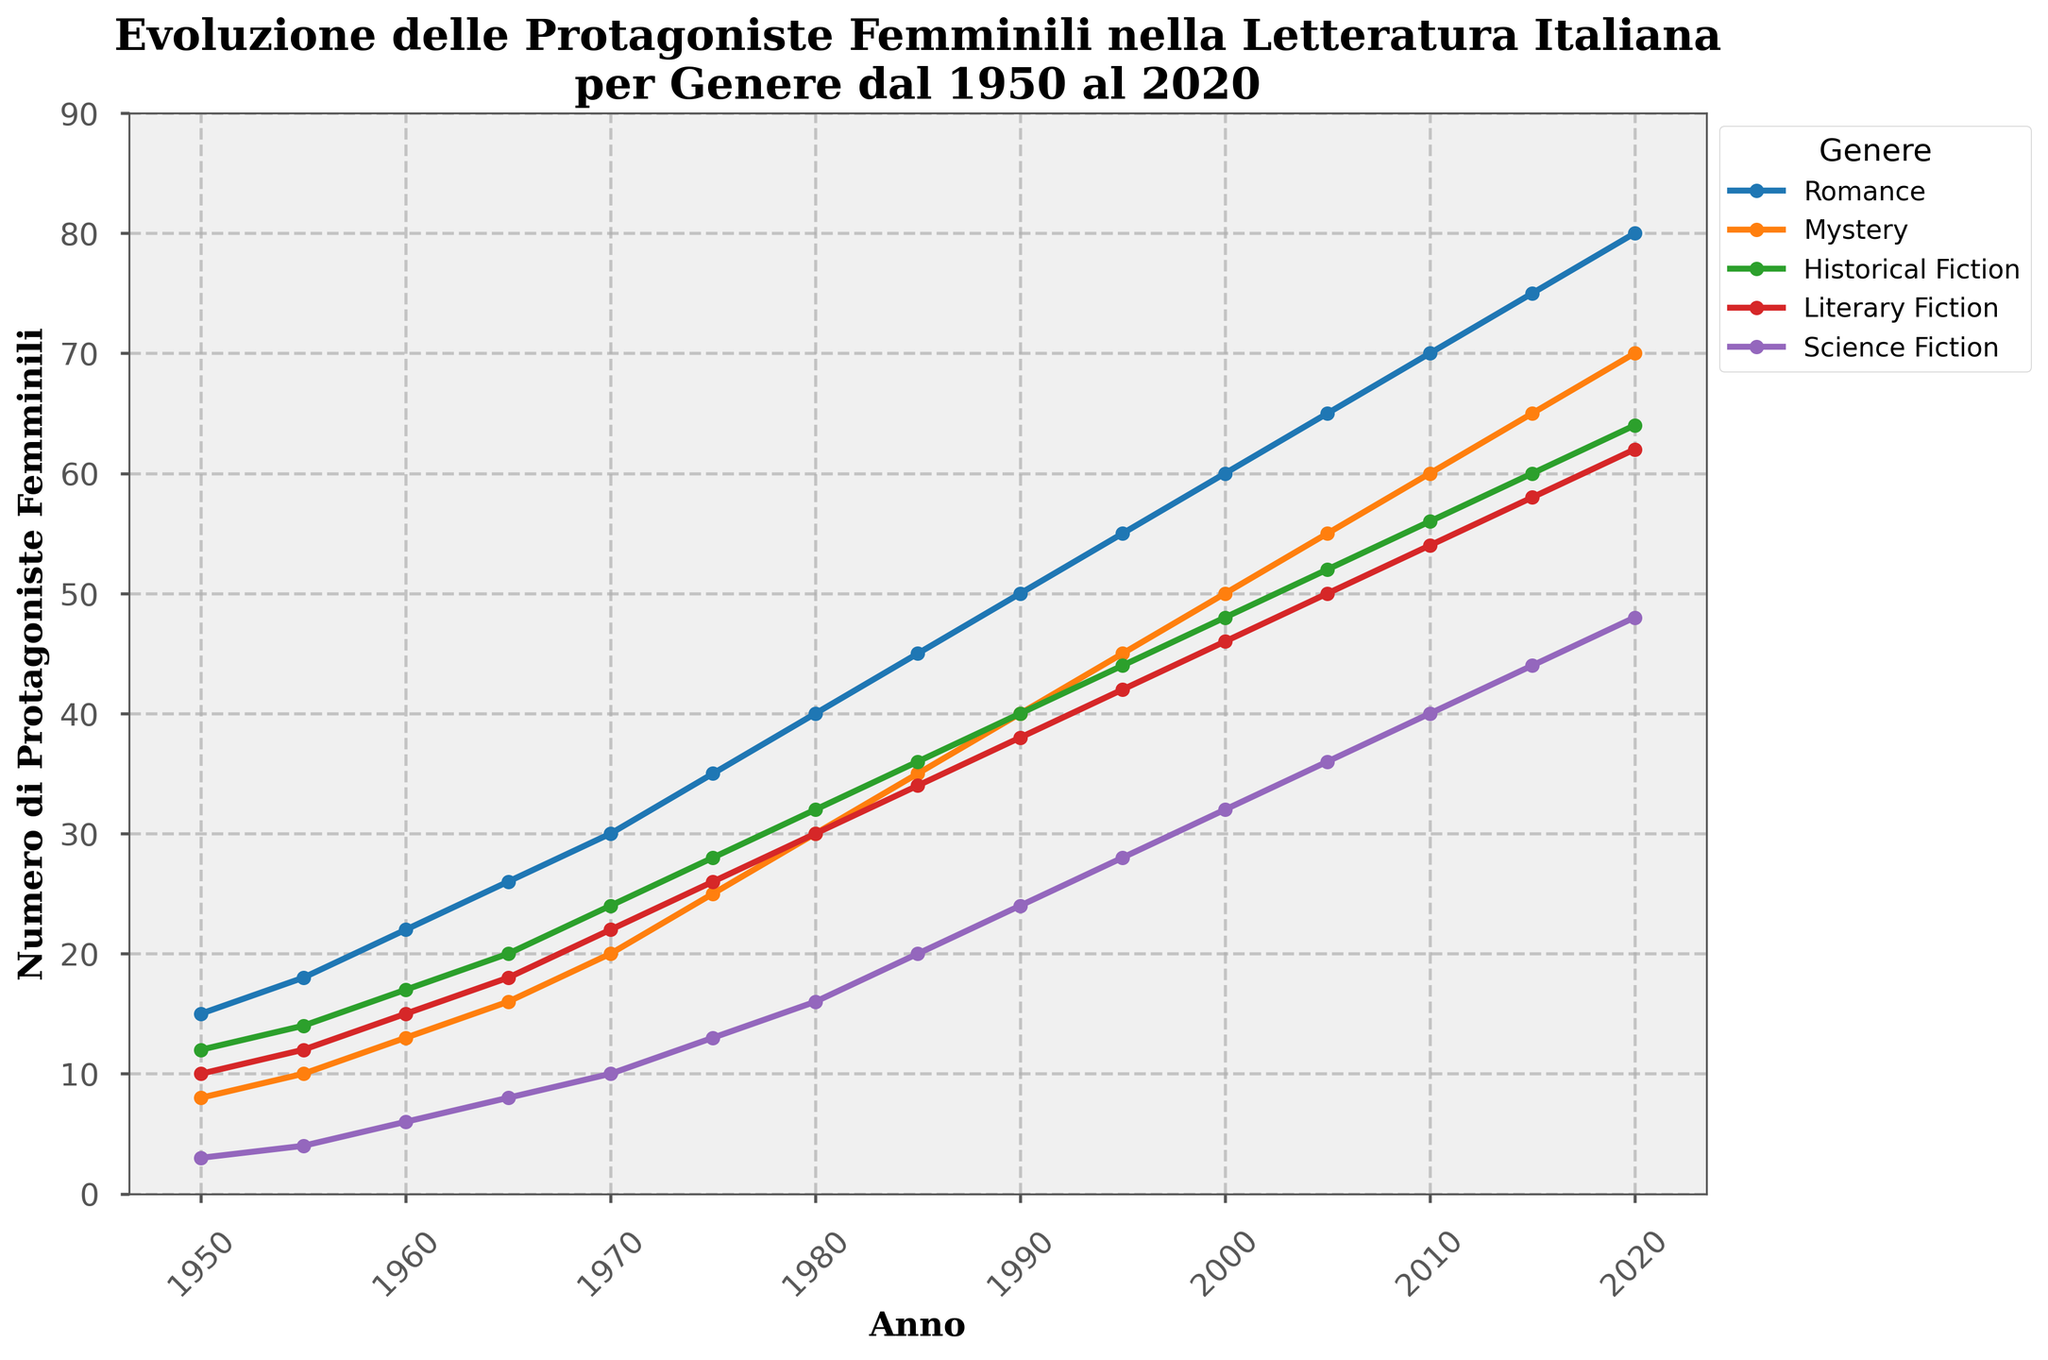Which genre has the highest number of female protagonists in 2020? By looking at the endpoint in the year 2020 for each line in the chart, the highest point clearly belongs to one of the lines.
Answer: Romance Which genre saw the smallest increase in the number of female protagonists from 1950 to 2020? By checking the endpoints for each genre, compute the difference between 2020 and 1950 figures. The smallest increase can be identified by comparing these differences.
Answer: Science Fiction Did the number of female protagonists in Mystery ever surpass Romance? Compare the two lines for Romance and Mystery over the entire timeline. Romance consistently has higher values than Mystery.
Answer: No Between which years did the Romance genre see the largest increase in female protagonists? Find the years between which the slope of the Romance line is the steepest by comparing the differences between consecutive points. The largest increase is between 2015 and 2020.
Answer: 2015 to 2020 On average, how many more female protagonists are featured in Literary Fiction per decade? Calculate the average difference for Literary Fiction for each decade by taking differences between decade points and finding the average.
Answer: 4 How did the number of female protagonists in Science Fiction change from 1970 to 1980? Check the values for Science Fiction in 1970 (10) and 1980 (16), and compute the difference: 16 - 10 = 6.
Answer: Increased by 6 In which year did Historical Fiction first surpass 20 female protagonists? Identify the earliest year where the value for Historical Fiction is greater than 20 by checking points from 1950 to 2020.
Answer: 1970 Which genre showed the most steady increase over time? Observe the smoothness and consistency of each line. Romance seems to have the most consistent upward trend.
Answer: Romance Which genre had approximately equal numbers of protagonists in 2000? Check the values for different genres in the year 2000 and find approximately equal points for different genres.
Answer: Literary Fiction and Historical Fiction 